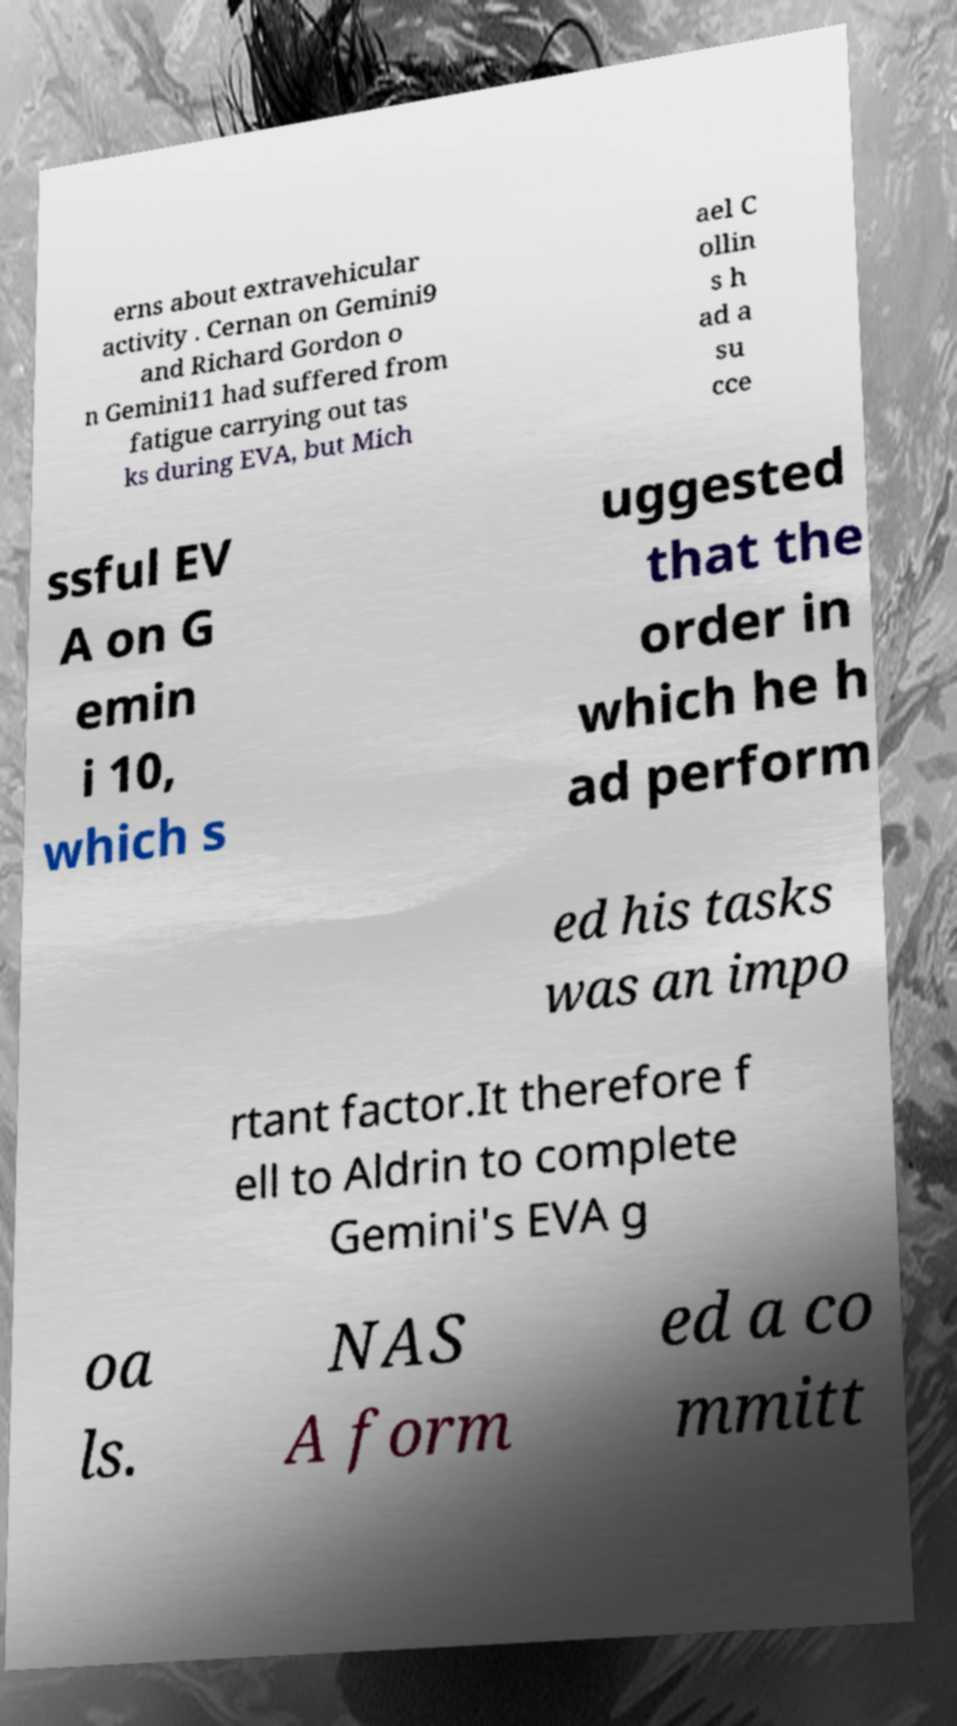There's text embedded in this image that I need extracted. Can you transcribe it verbatim? erns about extravehicular activity . Cernan on Gemini9 and Richard Gordon o n Gemini11 had suffered from fatigue carrying out tas ks during EVA, but Mich ael C ollin s h ad a su cce ssful EV A on G emin i 10, which s uggested that the order in which he h ad perform ed his tasks was an impo rtant factor.It therefore f ell to Aldrin to complete Gemini's EVA g oa ls. NAS A form ed a co mmitt 